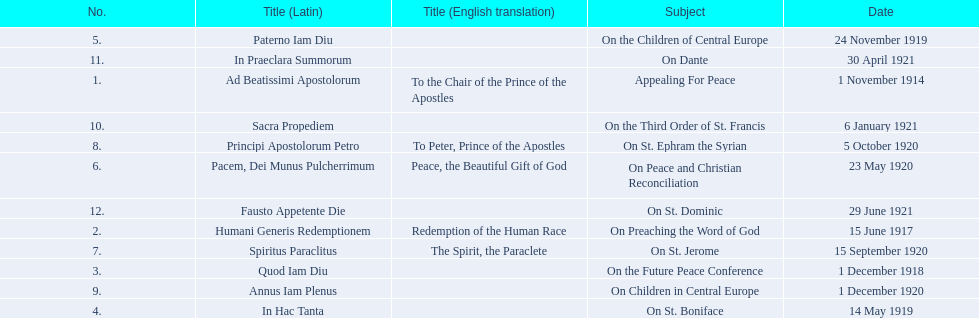Parse the full table. {'header': ['No.', 'Title (Latin)', 'Title (English translation)', 'Subject', 'Date'], 'rows': [['5.', 'Paterno Iam Diu', '', 'On the Children of Central Europe', '24 November 1919'], ['11.', 'In Praeclara Summorum', '', 'On Dante', '30 April 1921'], ['1.', 'Ad Beatissimi Apostolorum', 'To the Chair of the Prince of the Apostles', 'Appealing For Peace', '1 November 1914'], ['10.', 'Sacra Propediem', '', 'On the Third Order of St. Francis', '6 January 1921'], ['8.', 'Principi Apostolorum Petro', 'To Peter, Prince of the Apostles', 'On St. Ephram the Syrian', '5 October 1920'], ['6.', 'Pacem, Dei Munus Pulcherrimum', 'Peace, the Beautiful Gift of God', 'On Peace and Christian Reconciliation', '23 May 1920'], ['12.', 'Fausto Appetente Die', '', 'On St. Dominic', '29 June 1921'], ['2.', 'Humani Generis Redemptionem', 'Redemption of the Human Race', 'On Preaching the Word of God', '15 June 1917'], ['7.', 'Spiritus Paraclitus', 'The Spirit, the Paraclete', 'On St. Jerome', '15 September 1920'], ['3.', 'Quod Iam Diu', '', 'On the Future Peace Conference', '1 December 1918'], ['9.', 'Annus Iam Plenus', '', 'On Children in Central Europe', '1 December 1920'], ['4.', 'In Hac Tanta', '', 'On St. Boniface', '14 May 1919']]} What are all the subjects? Appealing For Peace, On Preaching the Word of God, On the Future Peace Conference, On St. Boniface, On the Children of Central Europe, On Peace and Christian Reconciliation, On St. Jerome, On St. Ephram the Syrian, On Children in Central Europe, On the Third Order of St. Francis, On Dante, On St. Dominic. Which occurred in 1920? On Peace and Christian Reconciliation, On St. Jerome, On St. Ephram the Syrian, On Children in Central Europe. Which occurred in may of that year? On Peace and Christian Reconciliation. 